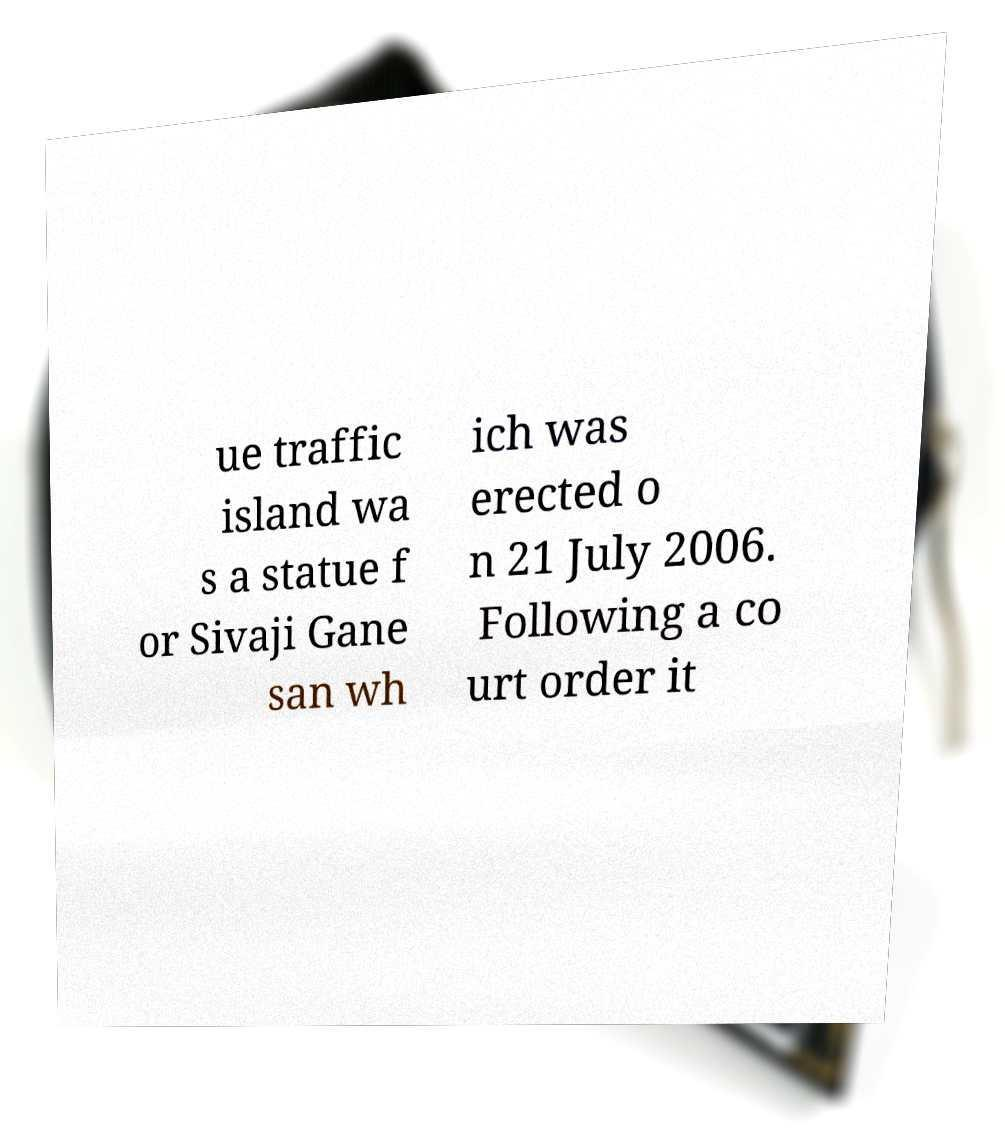I need the written content from this picture converted into text. Can you do that? ue traffic island wa s a statue f or Sivaji Gane san wh ich was erected o n 21 July 2006. Following a co urt order it 